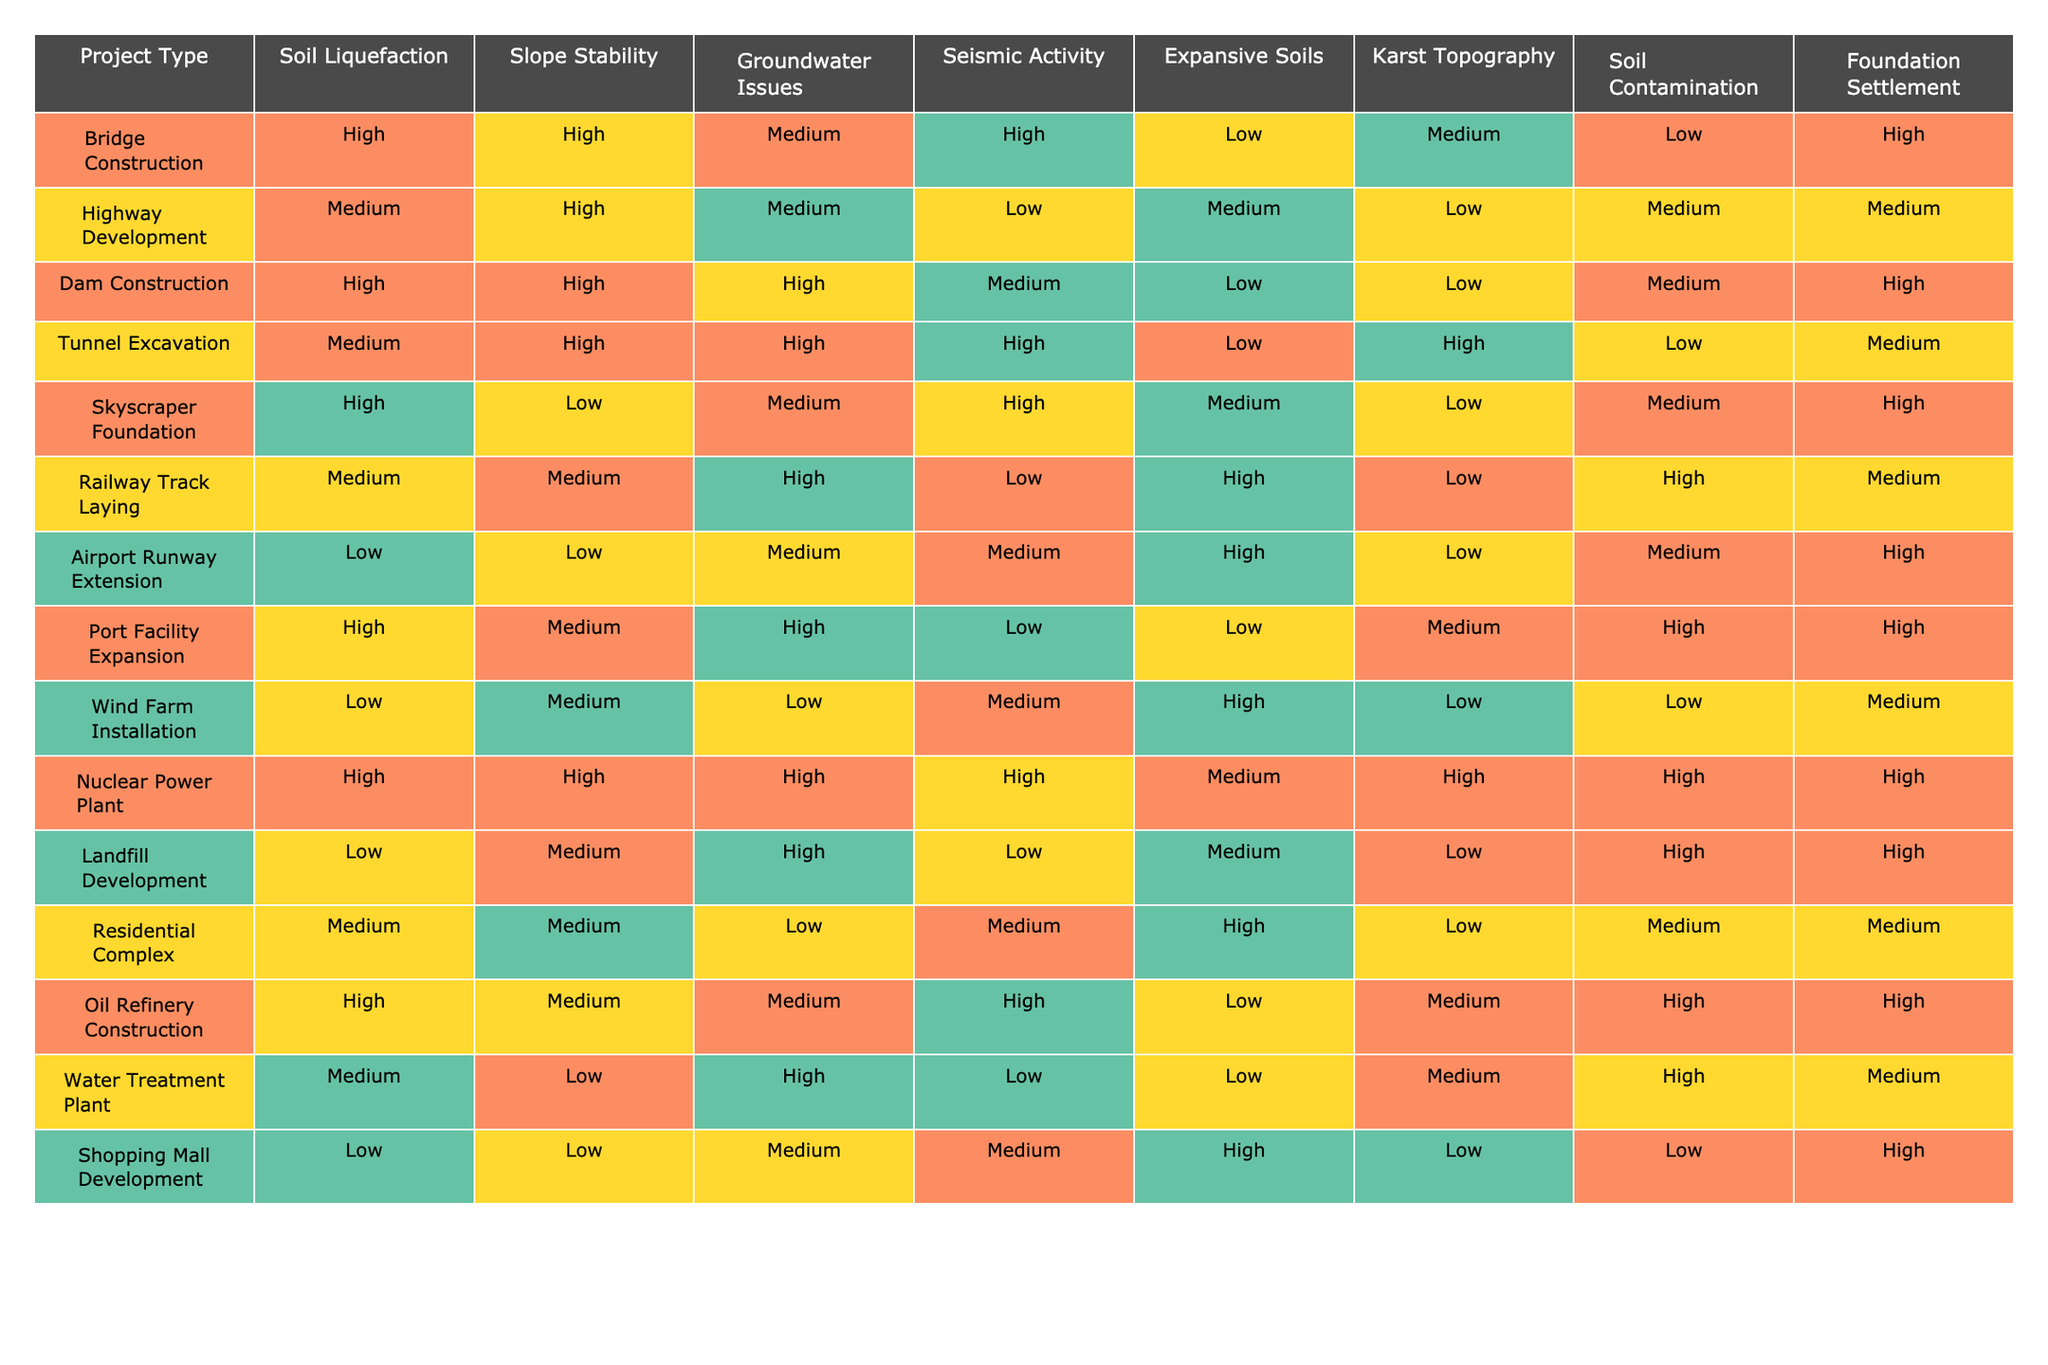What is the risk level for soil liquefaction in Highway Development? In the 'Highway Development' row, the risk level for soil liquefaction is indicated as 'Medium'.
Answer: Medium Which project type has the highest risk for seismic activity? The 'Nuclear Power Plant' row lists the risk for seismic activity as 'High', which is the highest among all project types presented in the table.
Answer: Nuclear Power Plant How many project types have a 'Low' risk for Karst Topography? There are three project types listed with 'Low' risk for Karst Topography: Airport Runway Extension, Wind Farm Installation, and Landfill Development.
Answer: 3 Is it true that residential complexes have medium risks for both foundation settlement and slope stability? In the 'Residential Complex' row, the risks for foundation settlement and slope stability are both listed as 'Medium', confirming the statement as true.
Answer: True What is the average risk level for groundwater issues across all project types? The risk levels for groundwater issues are: Medium, Medium, High, High, Medium, High, Medium, High, Low, Low, Medium, Medium, and High. Adding these up gives a total score of 10 Medium, 6 High, and 3 Low. Using a numerical scale (Low=1, Medium=2, High=3), the average is calculated as (10*2 + 6*3 + 3*1) / 19 = (20 + 18 + 3) / 19 = 41 / 19, which simplifies to approximately 2.16 or slightly above Medium.
Answer: Medium Which project type has the lowest risk for soil contamination? The project type 'Airport Runway Extension' shows a soil contamination risk level of 'Low', making it the lowest in this category.
Answer: Airport Runway Extension How many project types have 'High' risk for both slope stability and soil liquefaction? The project types with 'High' risks in both slope stability and soil liquefaction are: Bridge Construction, Dam Construction, and Nuclear Power Plant. Therefore, there are three such project types.
Answer: 3 If we consider only projects with 'High' risks for expansive soils, how many such projects are there? The projects with 'High' risk for expansive soils are: Skyscraper Foundation and Airport Runway Extension, totaling 2 projects.
Answer: 2 What is the risk level for foundation settlement in Dam Construction? In the 'Dam Construction' row, the risk for foundation settlement is recorded as 'High'.
Answer: High Are there any project types that have 'Medium' risk for both groundwater issues and foundation settlement? Yes, both 'Highway Development' and 'Railway Track Laying' have 'Medium' risks for groundwater issues and foundation settlement.
Answer: Yes What is the total number of project types that have a 'High' risk for seismic activity? The project types that have a 'High' risk for seismic activity are: Bridge Construction, Tunnel Excavation, Nuclear Power Plant, and Oil Refinery Construction, amounting to four project types.
Answer: 4 